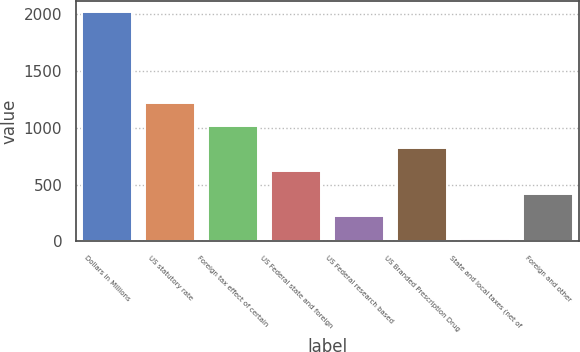<chart> <loc_0><loc_0><loc_500><loc_500><bar_chart><fcel>Dollars in Millions<fcel>US statutory rate<fcel>Foreign tax effect of certain<fcel>US Federal state and foreign<fcel>US Federal research based<fcel>US Branded Prescription Drug<fcel>State and local taxes (net of<fcel>Foreign and other<nl><fcel>2012<fcel>1215.2<fcel>1016<fcel>617.6<fcel>219.2<fcel>816.8<fcel>20<fcel>418.4<nl></chart> 